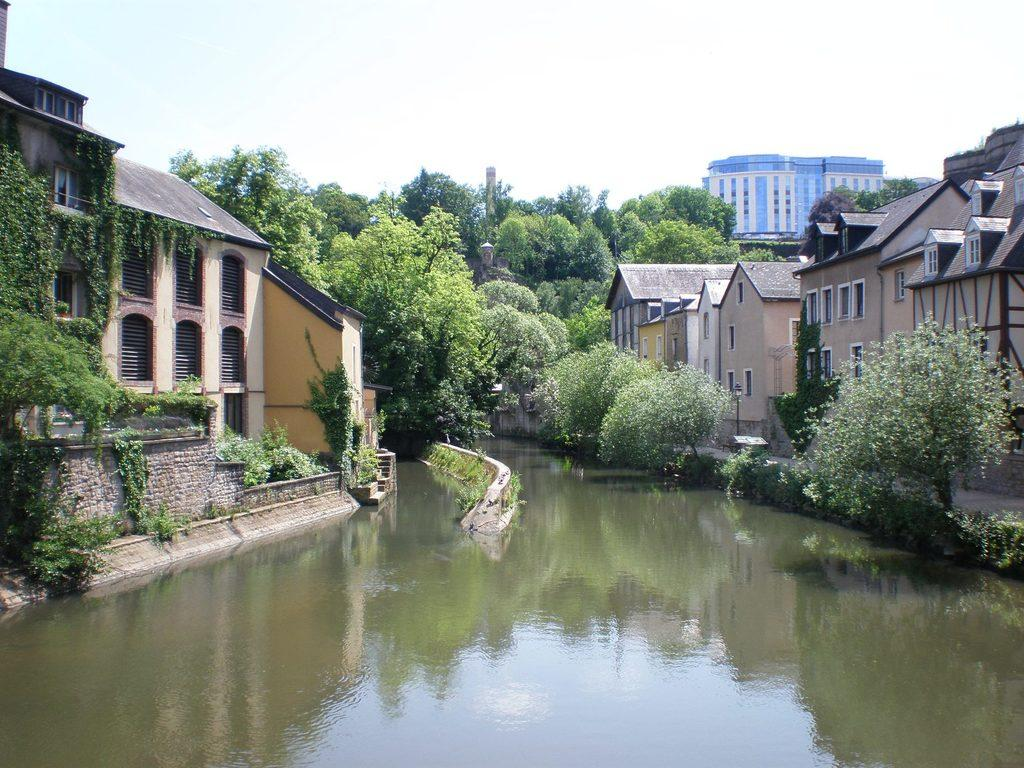What type of structures can be seen in the image? There are buildings in the image. What natural element is visible in the image? There is water visible in the image. What type of vegetation can be seen in the image? There are plants and trees in the image. What feature is present on one of the buildings? There is a chimney in the image. What part of the natural environment is visible in the image? The sky is visible in the image. Can you tell me how many planes are flying in the image? There are no planes visible in the image. What type of cake is being served in the image? There is no cake present in the image. 